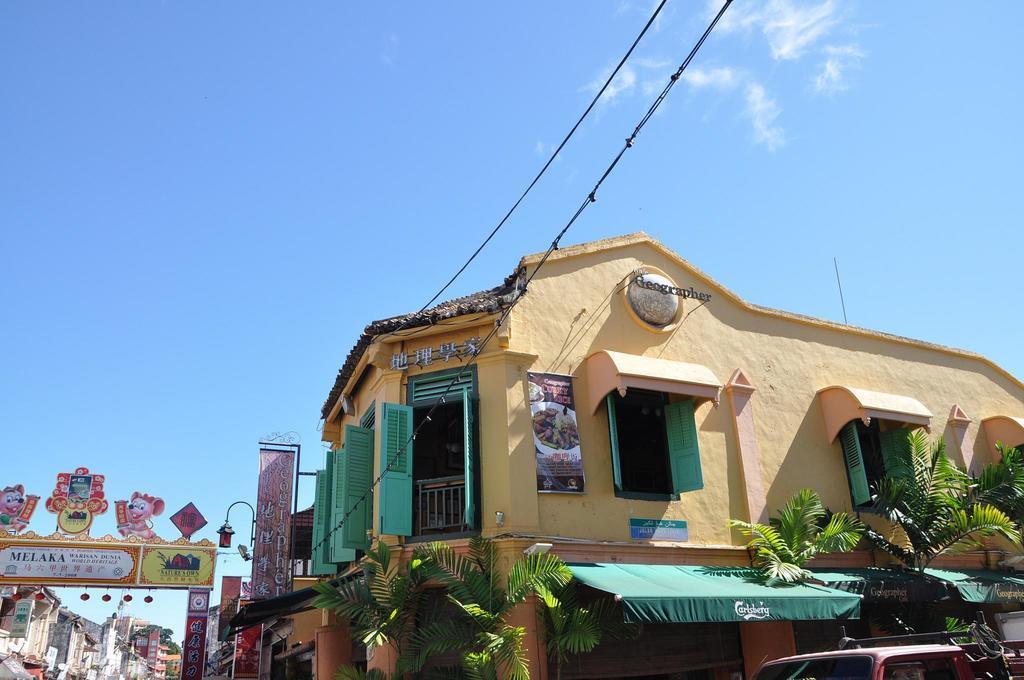Please provide a concise description of this image. This image is taken outdoors. At the top of the image there is the sky with clouds and there are two wires. In the middle of the image there are a few houses and buildings with walls, windows, doors, railings and roofs. There are a few plants. There is an arch and there are many boards with text on them. There is a light. At the right bottom of the image there is a vehicle. 